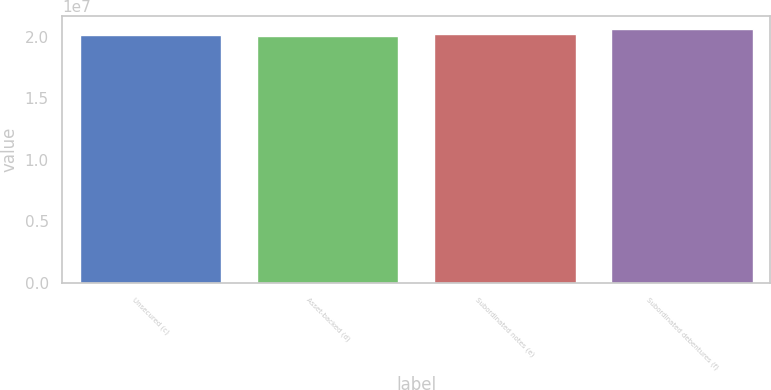Convert chart. <chart><loc_0><loc_0><loc_500><loc_500><bar_chart><fcel>Unsecured (c)<fcel>Asset-backed (d)<fcel>Subordinated notes (e)<fcel>Subordinated debentures (f)<nl><fcel>2.0158e+07<fcel>2.0102e+07<fcel>2.0214e+07<fcel>2.06621e+07<nl></chart> 